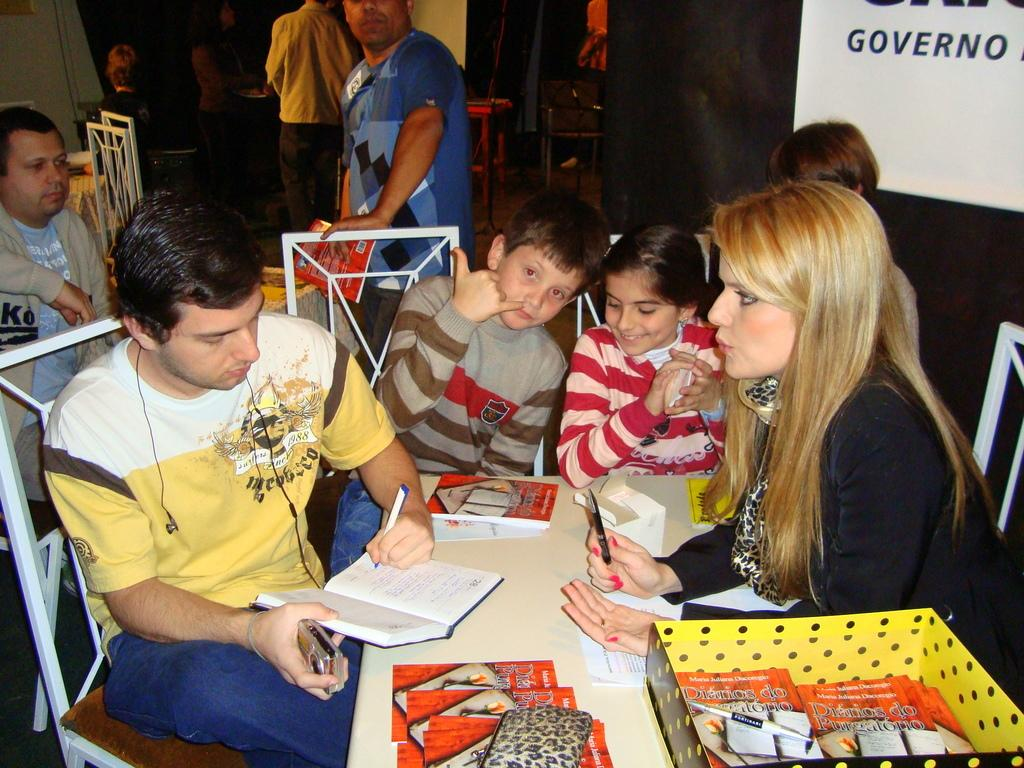<image>
Share a concise interpretation of the image provided. A man siging books with books on the table that say Diarios 